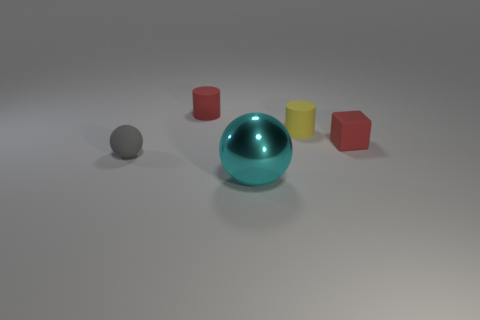Add 1 gray rubber objects. How many objects exist? 6 Subtract 0 brown balls. How many objects are left? 5 Subtract all blocks. How many objects are left? 4 Subtract 2 cylinders. How many cylinders are left? 0 Subtract all green blocks. Subtract all blue cylinders. How many blocks are left? 1 Subtract all gray cylinders. How many yellow balls are left? 0 Subtract all big yellow objects. Subtract all large things. How many objects are left? 4 Add 5 cyan things. How many cyan things are left? 6 Add 4 small yellow objects. How many small yellow objects exist? 5 Subtract all cyan spheres. How many spheres are left? 1 